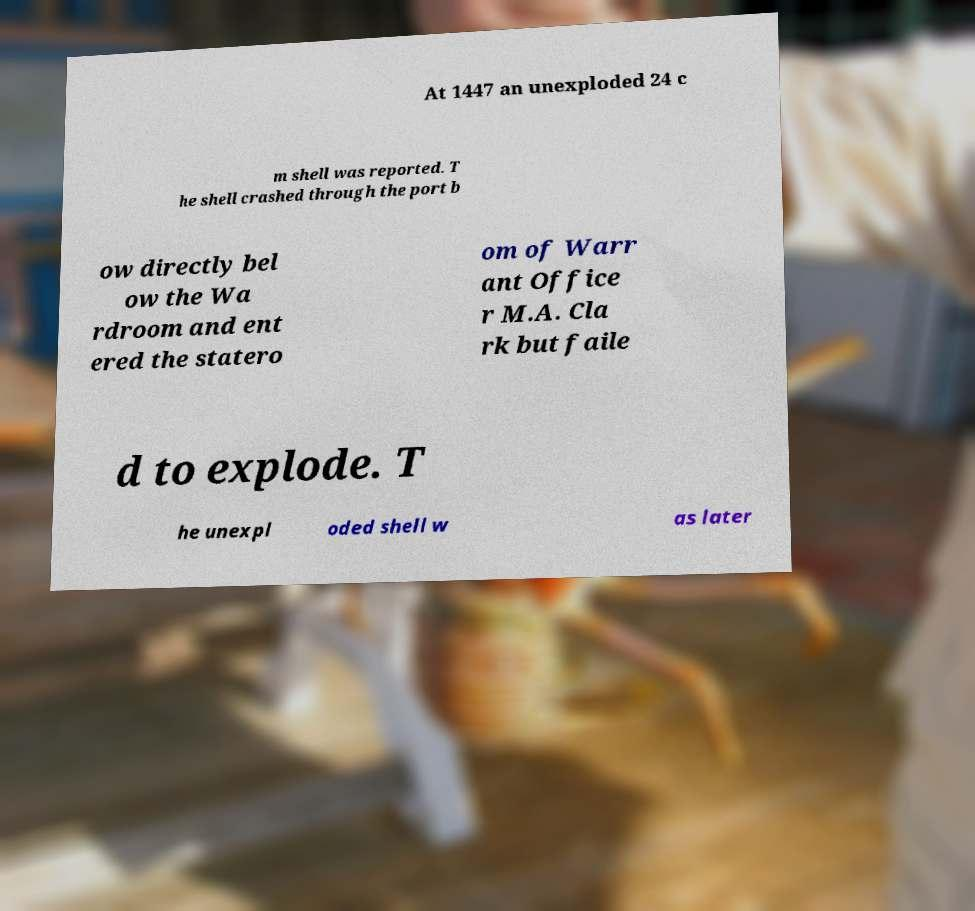What messages or text are displayed in this image? I need them in a readable, typed format. At 1447 an unexploded 24 c m shell was reported. T he shell crashed through the port b ow directly bel ow the Wa rdroom and ent ered the statero om of Warr ant Office r M.A. Cla rk but faile d to explode. T he unexpl oded shell w as later 